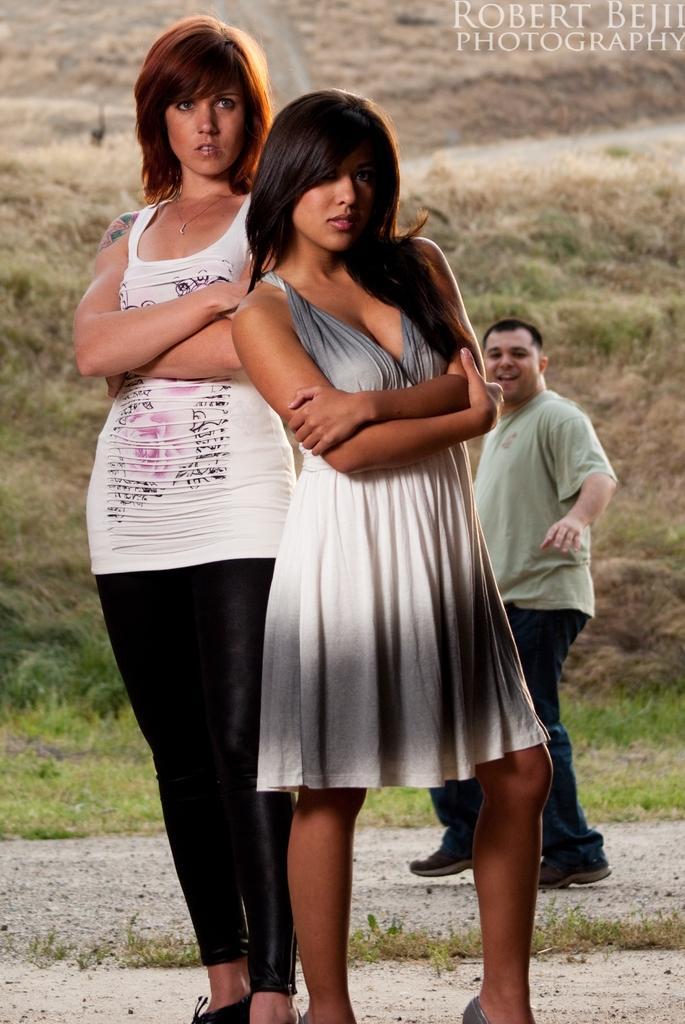Can you describe this image briefly? This is a poster. 2 women are standing. A man is present at the back. There is grass behind him. 